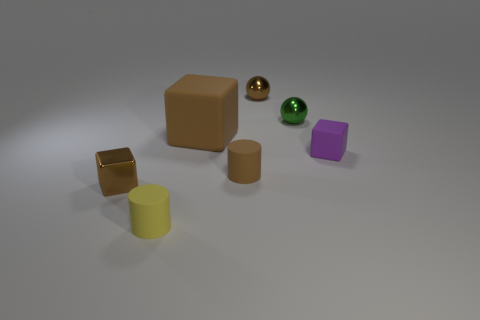Is the large rubber thing the same color as the tiny shiny block?
Provide a short and direct response. Yes. What is the shape of the tiny brown thing that is the same material as the yellow thing?
Offer a terse response. Cylinder. Is the material of the tiny cube to the left of the large brown rubber cube the same as the green thing?
Keep it short and to the point. Yes. There is another matte object that is the same color as the large object; what is its shape?
Your response must be concise. Cylinder. There is a small cylinder behind the small brown shiny cube; is its color the same as the metallic object that is in front of the big brown rubber cube?
Give a very brief answer. Yes. What number of small shiny things are right of the big matte object and in front of the brown sphere?
Give a very brief answer. 1. What material is the small green ball?
Your answer should be very brief. Metal. What is the shape of the yellow matte object that is the same size as the brown ball?
Your answer should be very brief. Cylinder. Is the cylinder right of the big rubber object made of the same material as the tiny cube right of the big matte object?
Provide a short and direct response. Yes. How many tiny blue rubber things are there?
Give a very brief answer. 0. 